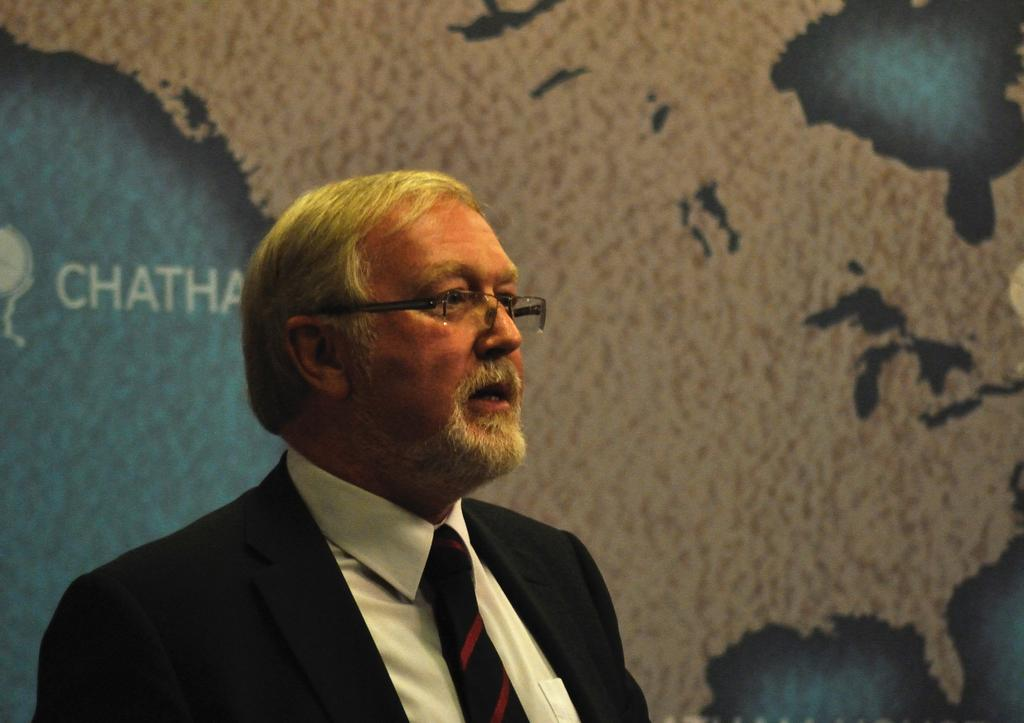What is present in the image? There is a person and a map in the image. Can you describe the map in the image? The map has some text on it. What type of cloth is covering the person's foot in the image? There is no cloth covering the person's foot in the image, as the person's feet are not visible. Where is the bedroom located in the image? There is no bedroom present in the image; it features a person and a map. 